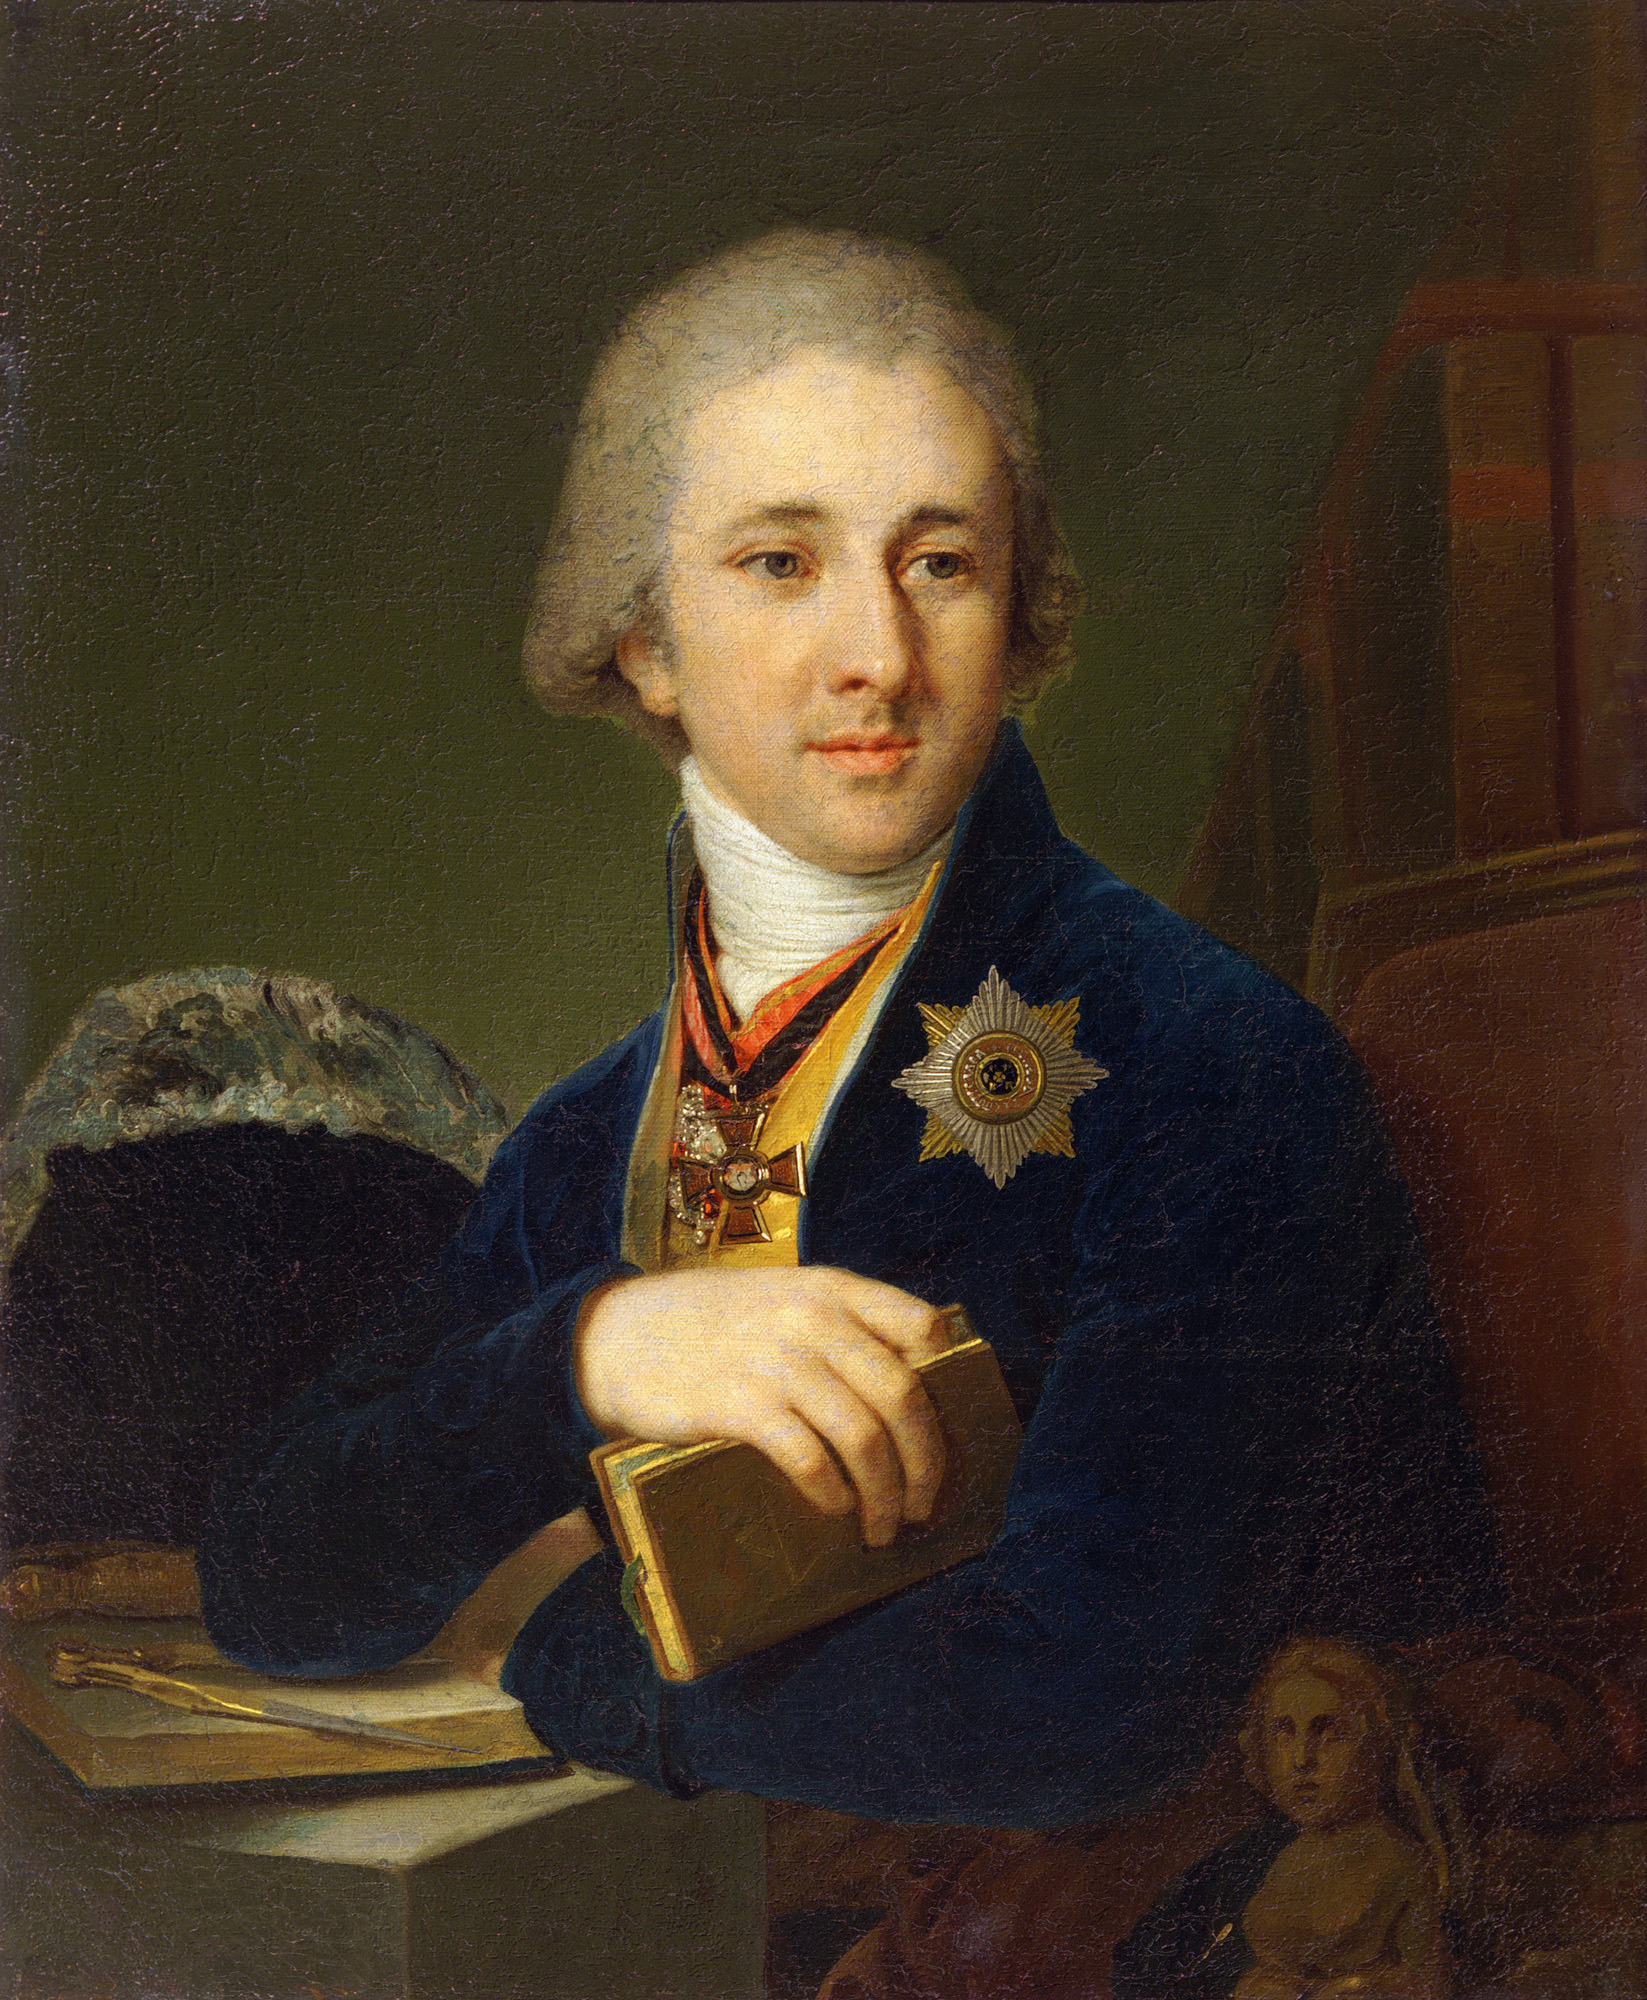Can you tell more about the significance of the medal worn by the man? The medal on the man's chest signifies a high honor, potentially granted for notable achievements, contributions to society, or distinct service. In the 18th century, such medals were often awarded by royalty or governmental bodies to individuals who excelled in fields such as the arts, military, science, or civil service. The specific design and inscriptions on the medal would provide further insights into the exact nature of his accomplishments or the entity bestowing the honor. 